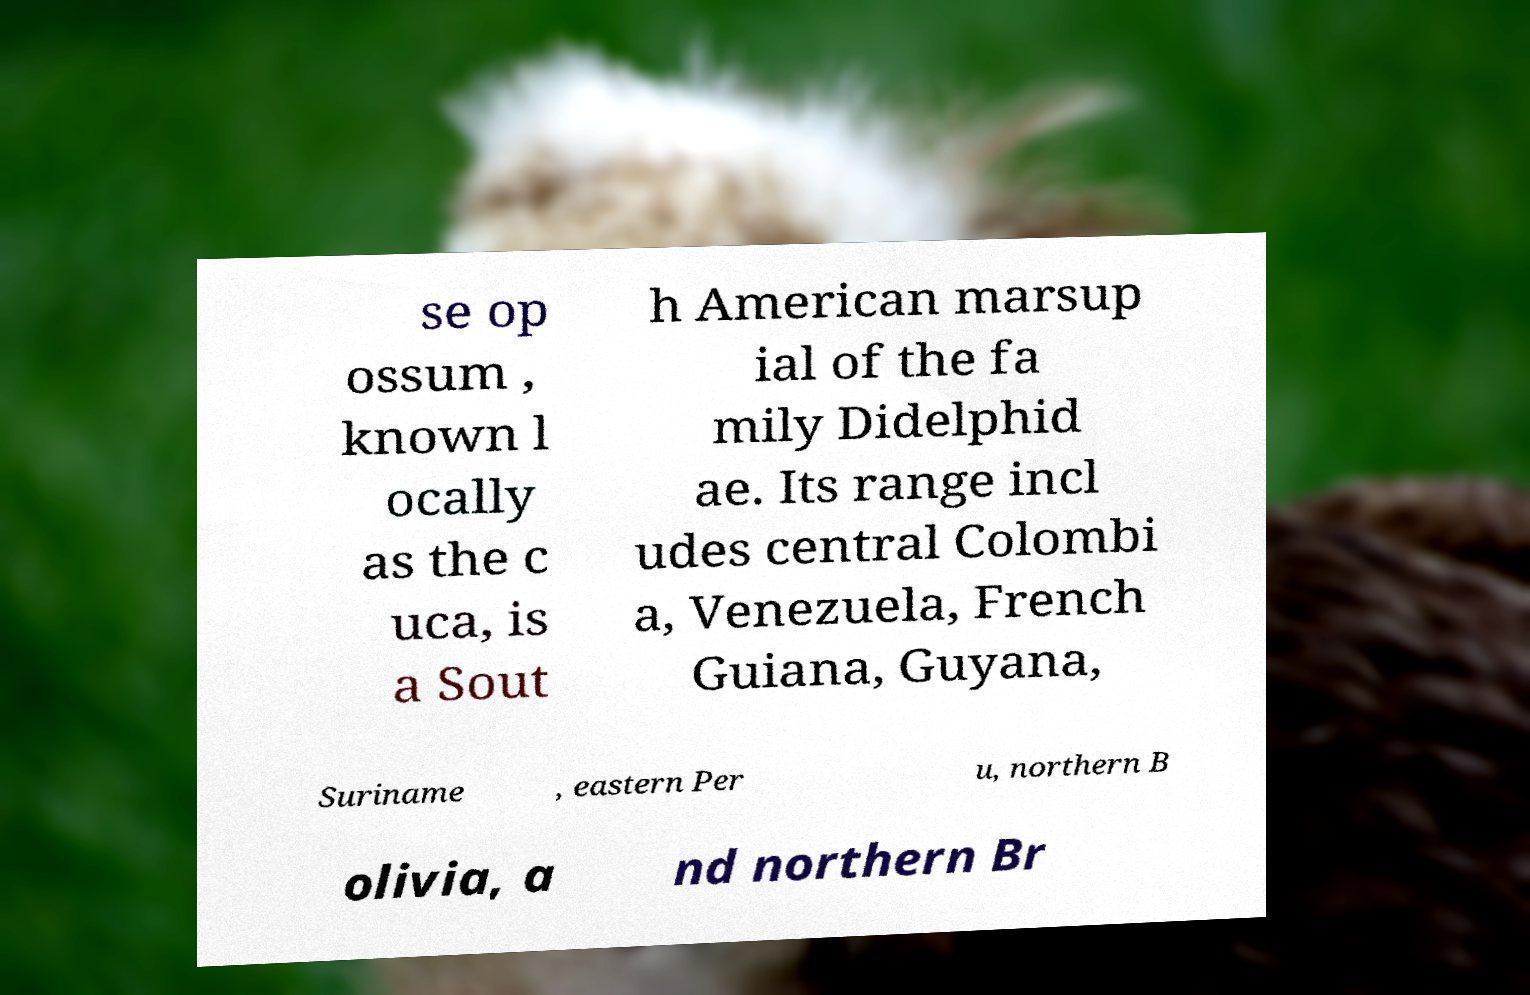Can you accurately transcribe the text from the provided image for me? se op ossum , known l ocally as the c uca, is a Sout h American marsup ial of the fa mily Didelphid ae. Its range incl udes central Colombi a, Venezuela, French Guiana, Guyana, Suriname , eastern Per u, northern B olivia, a nd northern Br 